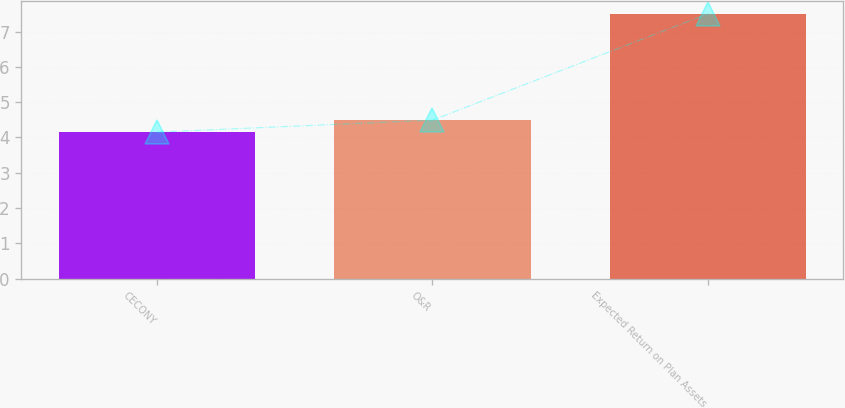Convert chart. <chart><loc_0><loc_0><loc_500><loc_500><bar_chart><fcel>CECONY<fcel>O&R<fcel>Expected Return on Plan Assets<nl><fcel>4.15<fcel>4.49<fcel>7.5<nl></chart> 